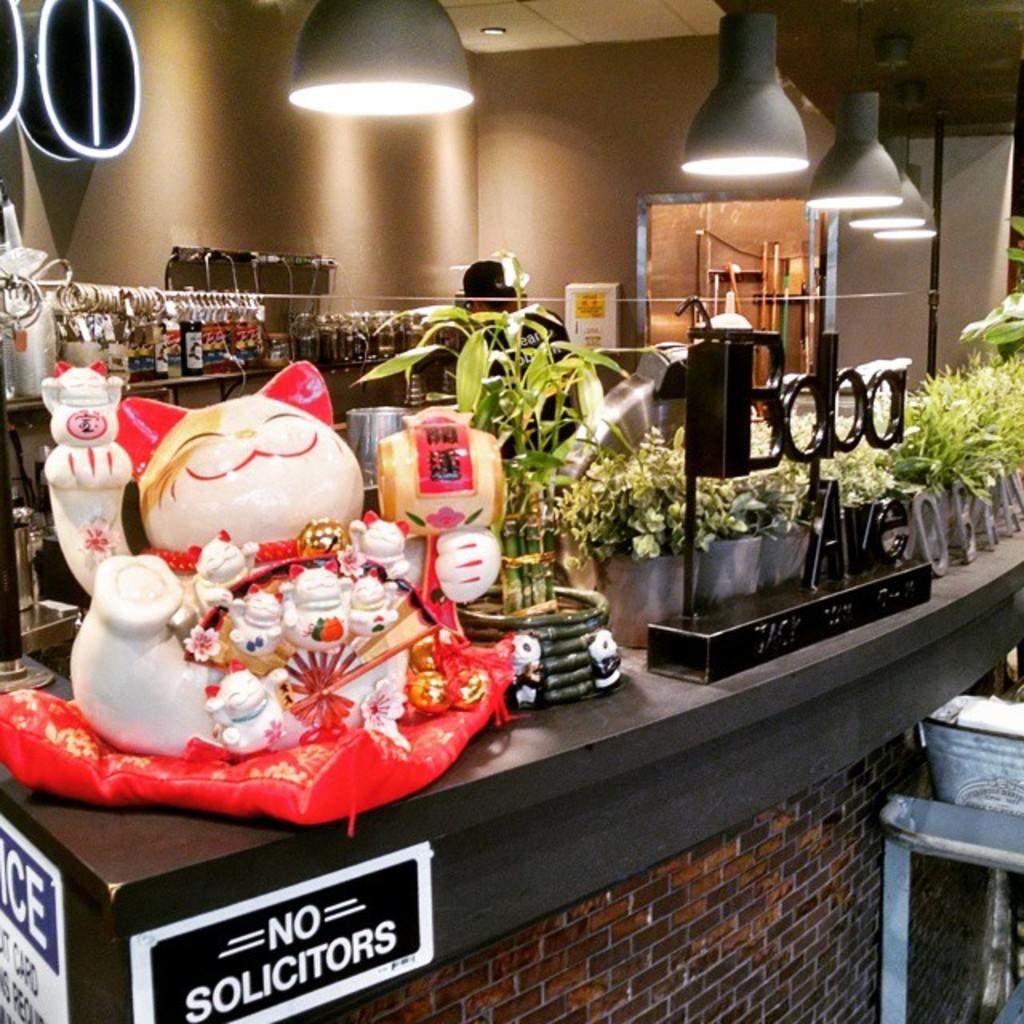<image>
Write a terse but informative summary of the picture. A sign banning solicitors is hanging just below the edge of a counter where a Chinese cat is sitting, surrounded by plants. 